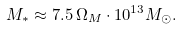<formula> <loc_0><loc_0><loc_500><loc_500>M _ { * } \approx 7 . 5 \, \Omega _ { M } \cdot 1 0 ^ { 1 3 } M _ { \odot } .</formula> 